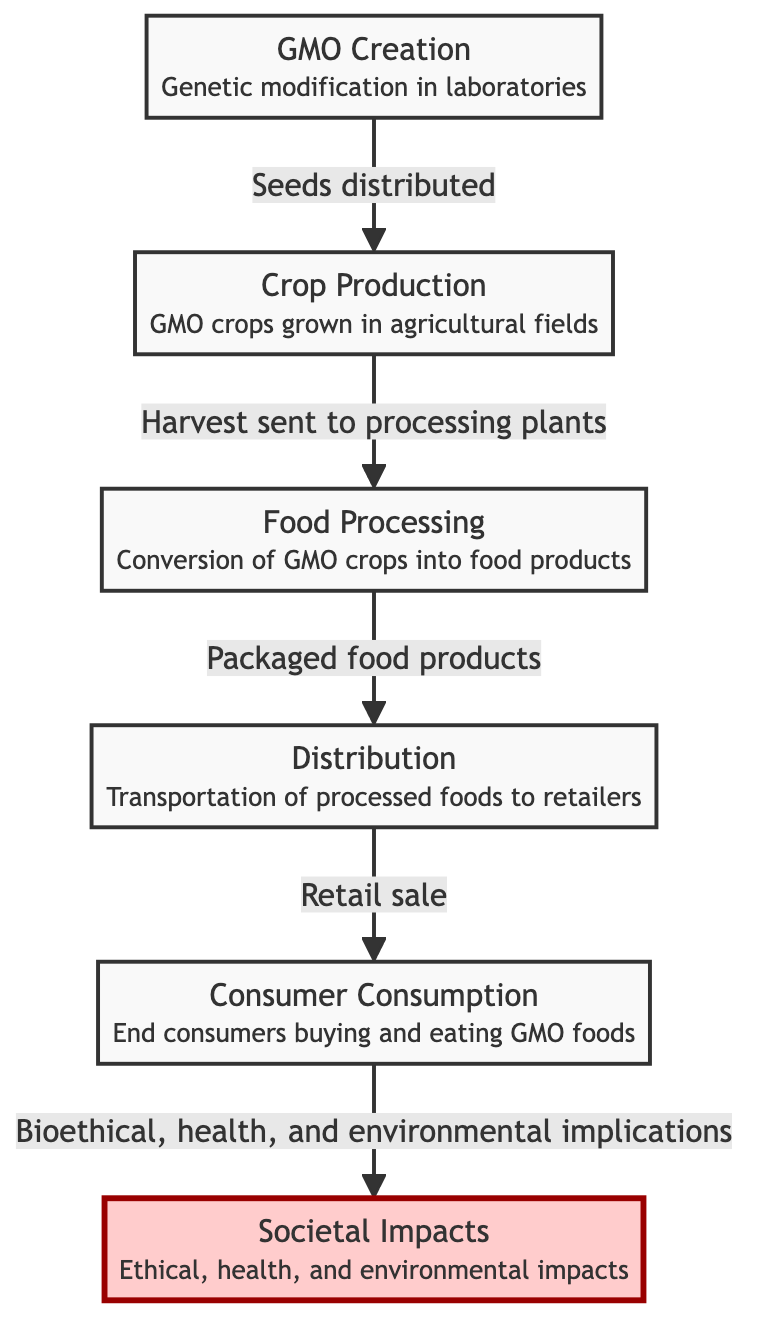What is the first step in the food chain? The diagram starts with "GMO Creation," which indicates that this is the first step where genetic modification occurs in laboratories.
Answer: GMO Creation How many steps are there in the food chain? By counting each node in the diagram, there are six distinct steps: GMO Creation, Crop Production, Food Processing, Distribution, Consumer Consumption, and Societal Impacts.
Answer: 6 What follows Crop Production in the food chain? The arrow from "Crop Production" leads directly to "Food Processing," indicating that the next step is processing the harvested GMO crops.
Answer: Food Processing What are the end consumers' actions in the food chain? The "Consumer Consumption" node notes that end consumers buy and eat GMO foods. This captures the actions taken by consumers after products reach retailers.
Answer: Buying and eating What is the relationship between Food Processing and Distribution? The diagram shows a direct flow from "Food Processing" to "Distribution," indicating that packaged food products are transported to retailers in this step.
Answer: Packaged food products What implications are noted under Societal Impacts? The diagram highlights that societal impacts include "Ethical, health, and environmental impacts," which suggests multiple areas of concern related to GMO foods.
Answer: Ethical, health, and environmental impacts What is the last step before societal impacts in the food chain? The penultimate step is "Consumer Consumption," where GMO foods are purchased and eaten by consumers, leading to the consideration of societal impacts.
Answer: Consumer Consumption How are GMOs distributed after processing? The "Distribution" node indicates that there is a flow from "Food Processing" to "Distribution," which involves the retail sale of the products created from GMO crops.
Answer: Transportation to retailers What is the connection between Genetic modification and Ethical implications? Genetic modification begins the process in "GMO Creation," which eventually connects to the last node "Societal Impacts," indicating that the ethical implications stem from all prior steps in the food chain.
Answer: Ethical implications stem from GMO Creation 